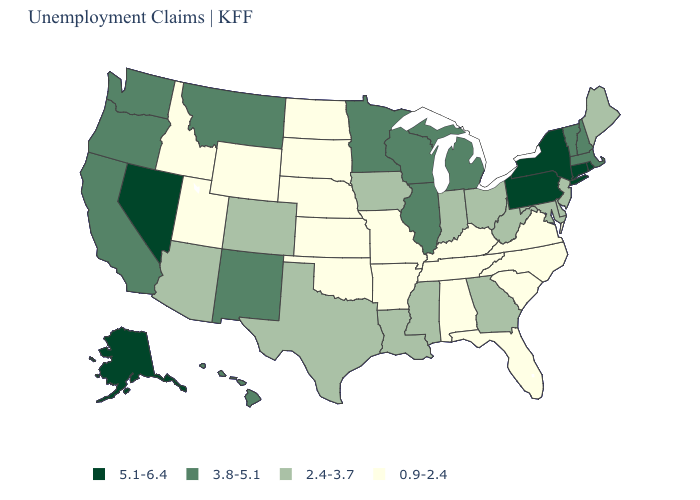What is the value of Tennessee?
Write a very short answer. 0.9-2.4. Name the states that have a value in the range 5.1-6.4?
Quick response, please. Alaska, Connecticut, Nevada, New York, Pennsylvania, Rhode Island. What is the value of Connecticut?
Short answer required. 5.1-6.4. What is the lowest value in states that border Arizona?
Give a very brief answer. 0.9-2.4. Name the states that have a value in the range 2.4-3.7?
Answer briefly. Arizona, Colorado, Delaware, Georgia, Indiana, Iowa, Louisiana, Maine, Maryland, Mississippi, New Jersey, Ohio, Texas, West Virginia. Among the states that border Georgia , which have the highest value?
Give a very brief answer. Alabama, Florida, North Carolina, South Carolina, Tennessee. Does the first symbol in the legend represent the smallest category?
Answer briefly. No. What is the highest value in the South ?
Give a very brief answer. 2.4-3.7. What is the value of Delaware?
Short answer required. 2.4-3.7. Does Tennessee have a higher value than Nevada?
Short answer required. No. Name the states that have a value in the range 2.4-3.7?
Keep it brief. Arizona, Colorado, Delaware, Georgia, Indiana, Iowa, Louisiana, Maine, Maryland, Mississippi, New Jersey, Ohio, Texas, West Virginia. Does the map have missing data?
Quick response, please. No. What is the value of Delaware?
Concise answer only. 2.4-3.7. What is the highest value in the USA?
Concise answer only. 5.1-6.4. Which states have the highest value in the USA?
Short answer required. Alaska, Connecticut, Nevada, New York, Pennsylvania, Rhode Island. 